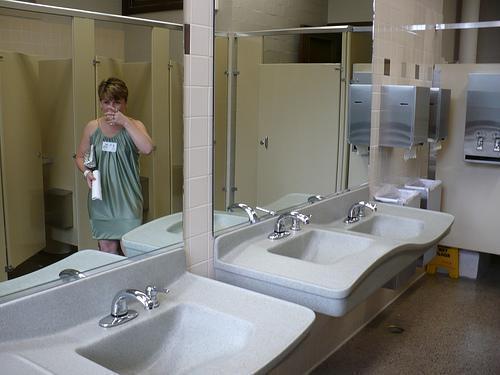How many mirrors can be seen?
Give a very brief answer. 2. How many sink faucets can be seen?
Give a very brief answer. 3. How many floor drains can be seen?
Give a very brief answer. 1. 